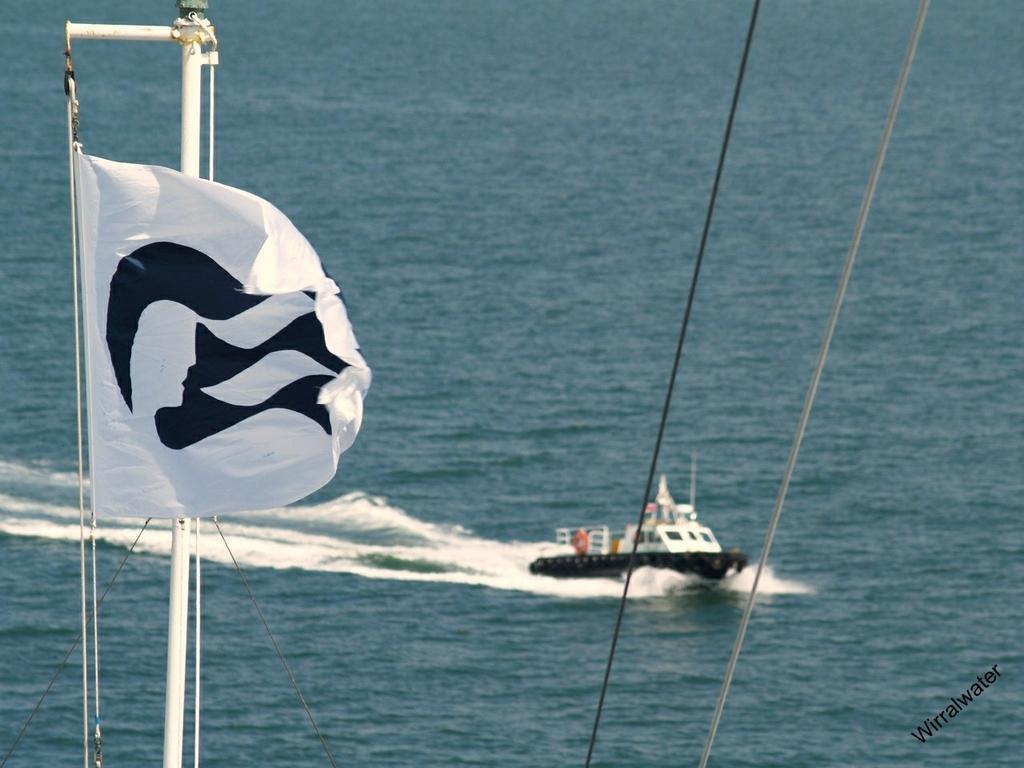How would you summarize this image in a sentence or two? In this image I see a white colored flag and a white rod. In the background I see a boat which is on the water. 